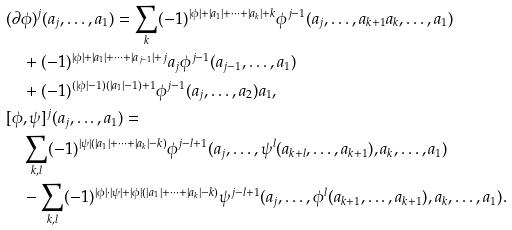Convert formula to latex. <formula><loc_0><loc_0><loc_500><loc_500>& ( \partial \phi ) ^ { j } ( a _ { j } , \dots , a _ { 1 } ) = \sum _ { k } ( - 1 ) ^ { | \phi | + | a _ { 1 } | + \cdots + | a _ { k } | + k } \phi ^ { j - 1 } ( a _ { j } , \dots , a _ { k + 1 } a _ { k } , \dots , a _ { 1 } ) \\ & \quad + ( - 1 ) ^ { | \phi | + | a _ { 1 } | + \cdots + | a _ { j - 1 } | + j } a _ { j } \phi ^ { j - 1 } ( a _ { j - 1 } , \dots , a _ { 1 } ) \\ & \quad + ( - 1 ) ^ { ( | \phi | - 1 ) ( | a _ { 1 } | - 1 ) + 1 } \phi ^ { j - 1 } ( a _ { j } , \dots , a _ { 2 } ) a _ { 1 } , \\ & [ \phi , \psi ] ^ { j } ( a _ { j } , \dots , a _ { 1 } ) = \\ & \quad \sum _ { k , l } ( - 1 ) ^ { | \psi | ( | a _ { 1 } | + \cdots + | a _ { k } | - k ) } \phi ^ { j - l + 1 } ( a _ { j } , \dots , \psi ^ { l } ( a _ { k + l } , \dots , a _ { k + 1 } ) , a _ { k } , \dots , a _ { 1 } ) \\ & \quad - \sum _ { k , l } ( - 1 ) ^ { | \phi | \cdot | \psi | + | \phi | ( | a _ { 1 } | + \cdots + | a _ { k } | - k ) } \psi ^ { j - l + 1 } ( a _ { j } , \dots , \phi ^ { l } ( a _ { k + 1 } , \dots , a _ { k + 1 } ) , a _ { k } , \dots , a _ { 1 } ) .</formula> 